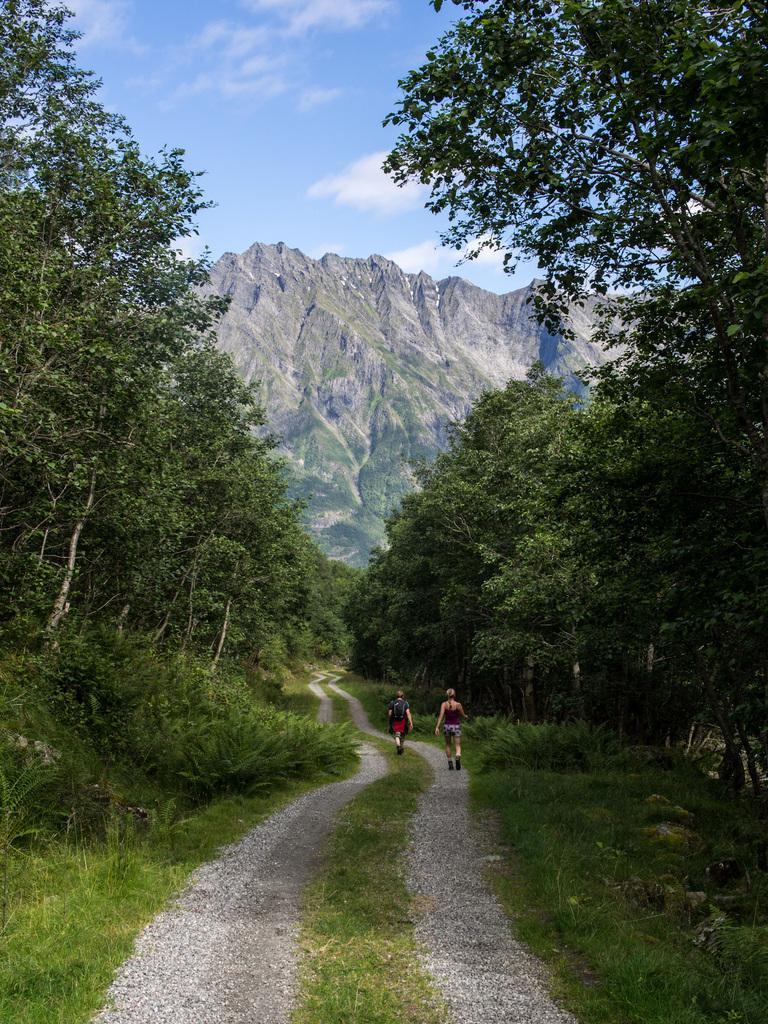Describe this image in one or two sentences. In this image there are two people walking on the path, there are trees, plants, grass, mountains and some clouds in the sky. 